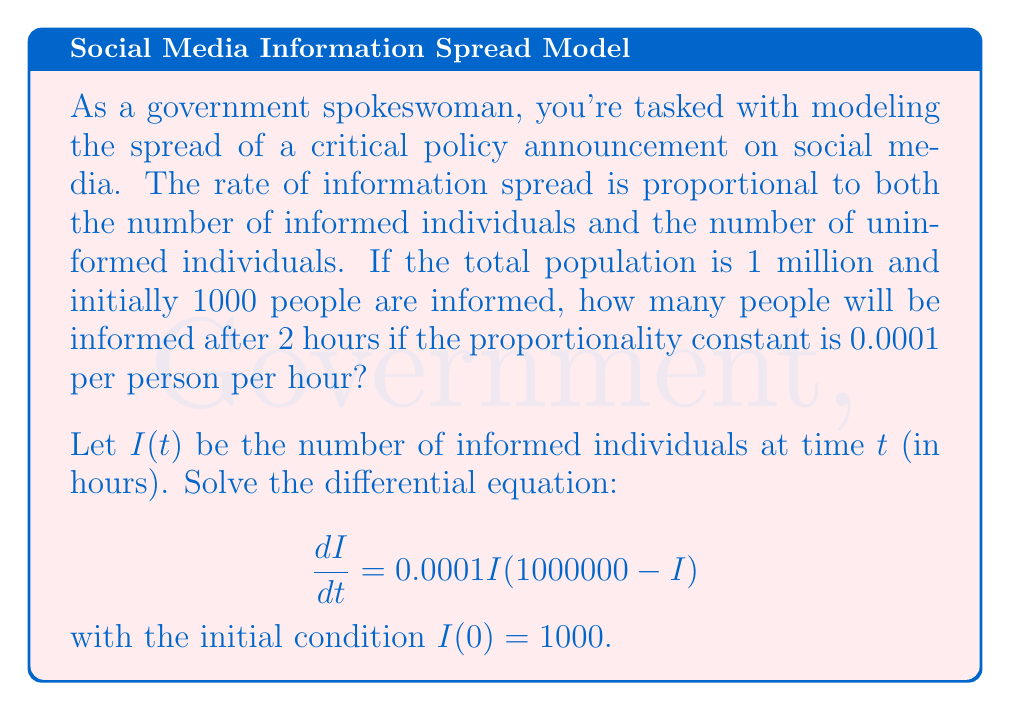Show me your answer to this math problem. Let's solve this step-by-step:

1) The given differential equation is a logistic growth model:

   $$\frac{dI}{dt} = 0.0001I(1000000 - I)$$

2) This can be rewritten as:

   $$\frac{dI}{dt} = 100I(1 - \frac{I}{1000000})$$

3) The general solution to this logistic equation is:

   $$I(t) = \frac{1000000}{1 + Ce^{-100t}}$$

   where $C$ is a constant to be determined from the initial condition.

4) Using the initial condition $I(0) = 1000$:

   $$1000 = \frac{1000000}{1 + C}$$

5) Solving for $C$:

   $$C = \frac{1000000}{1000} - 1 = 999$$

6) So, our specific solution is:

   $$I(t) = \frac{1000000}{1 + 999e^{-100t}}$$

7) To find $I(2)$, we substitute $t = 2$:

   $$I(2) = \frac{1000000}{1 + 999e^{-200}}$$

8) Calculating this value:

   $$I(2) \approx 732,116$$

Therefore, after 2 hours, approximately 732,116 people will be informed.
Answer: 732,116 people 